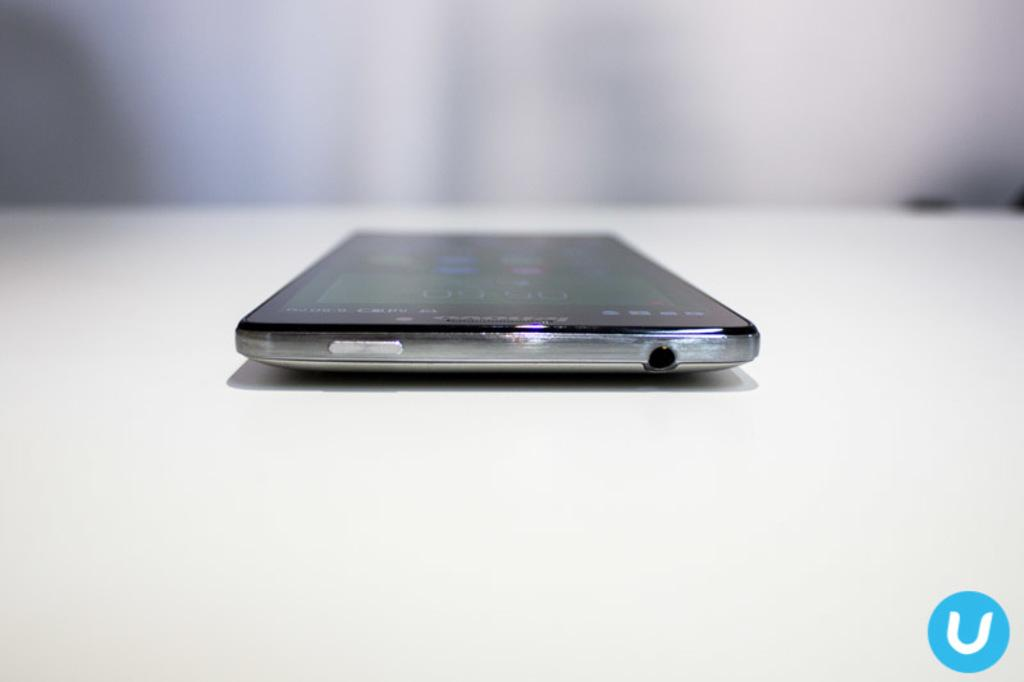Where was the image taken? The image was taken indoors. What is located at the bottom of the image? There is a table at the bottom of the image. What can be seen in the background of the image? There is a wall in the background of the image. What object is on the table in the middle of the image? There is a mobile phone in the middle of the image, on the table. Can you hear the lamp crying in the image? There is no lamp present in the image, and therefore it cannot be crying. 